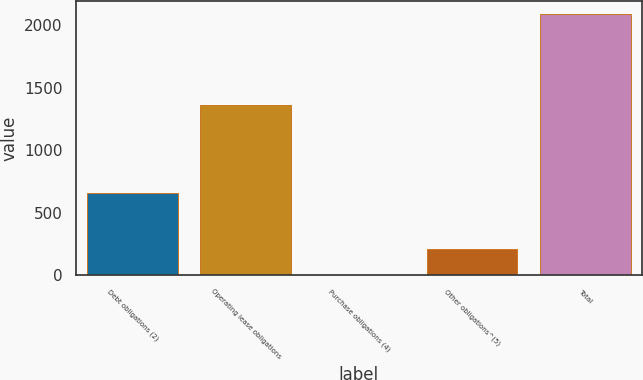Convert chart. <chart><loc_0><loc_0><loc_500><loc_500><bar_chart><fcel>Debt obligations (2)<fcel>Operating lease obligations<fcel>Purchase obligations (4)<fcel>Other obligations^(5)<fcel>Total<nl><fcel>653.1<fcel>1362.1<fcel>0.5<fcel>209.7<fcel>2092.5<nl></chart> 